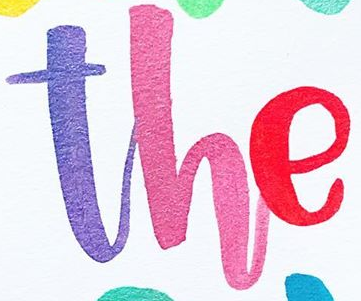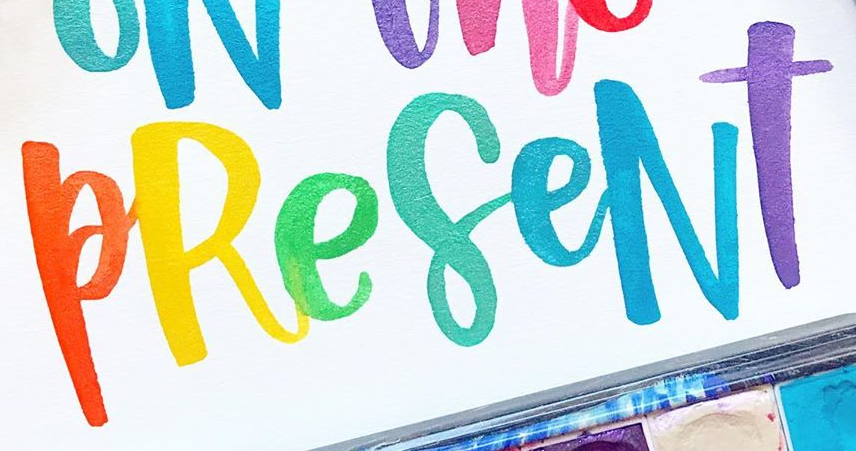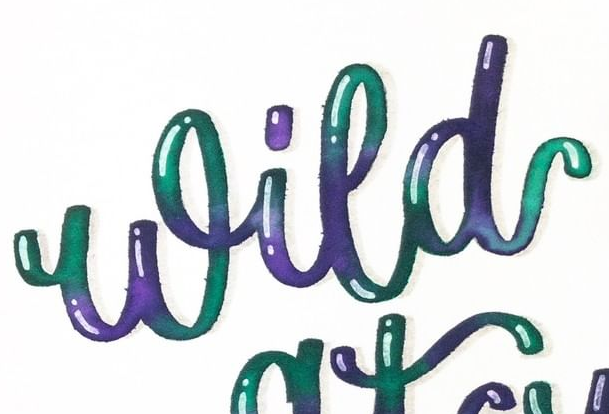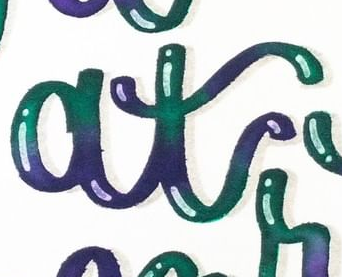What words are shown in these images in order, separated by a semicolon? The; PReseNT; Wild; at 